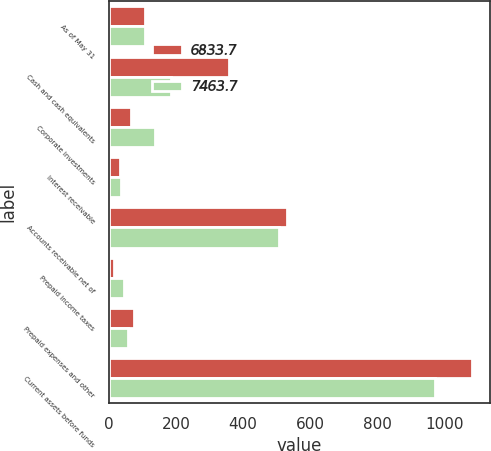Convert chart. <chart><loc_0><loc_0><loc_500><loc_500><stacked_bar_chart><ecel><fcel>As of May 31<fcel>Cash and cash equivalents<fcel>Corporate investments<fcel>Interest receivable<fcel>Accounts receivable net of<fcel>Prepaid income taxes<fcel>Prepaid expenses and other<fcel>Current assets before funds<nl><fcel>6833.7<fcel>107.3<fcel>358.2<fcel>66<fcel>32.2<fcel>531.4<fcel>17<fcel>75.8<fcel>1080.6<nl><fcel>7463.7<fcel>107.3<fcel>184.6<fcel>138.8<fcel>35.9<fcel>507.5<fcel>45<fcel>58.3<fcel>970.1<nl></chart> 